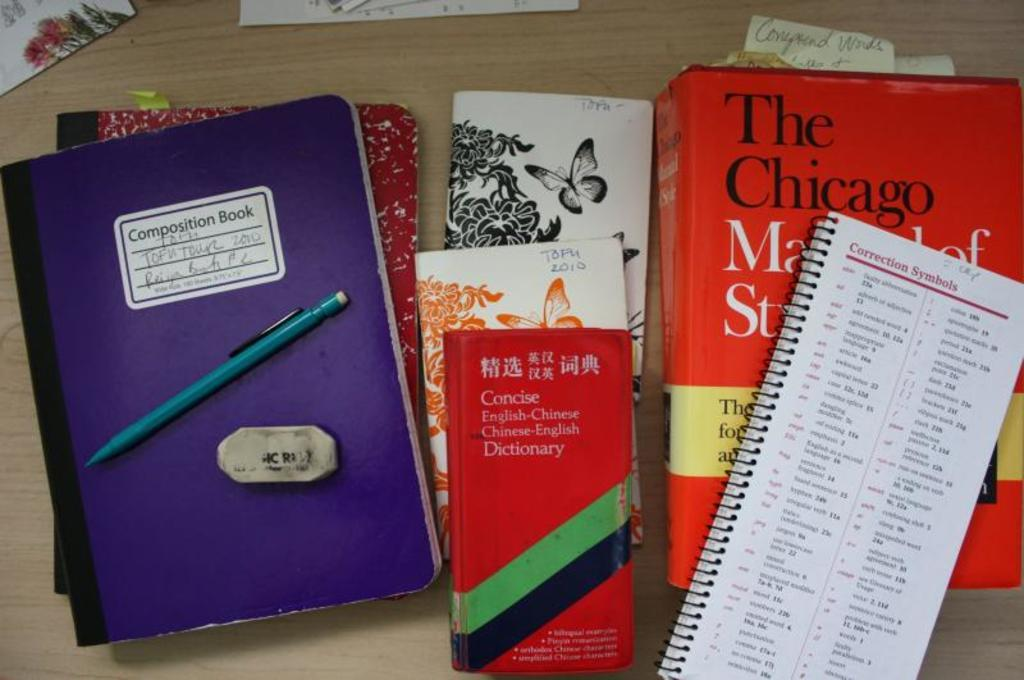<image>
Provide a brief description of the given image. A composition book, an English-Chinese dictionary and some notebooks and text books placed on a wooden surface. 